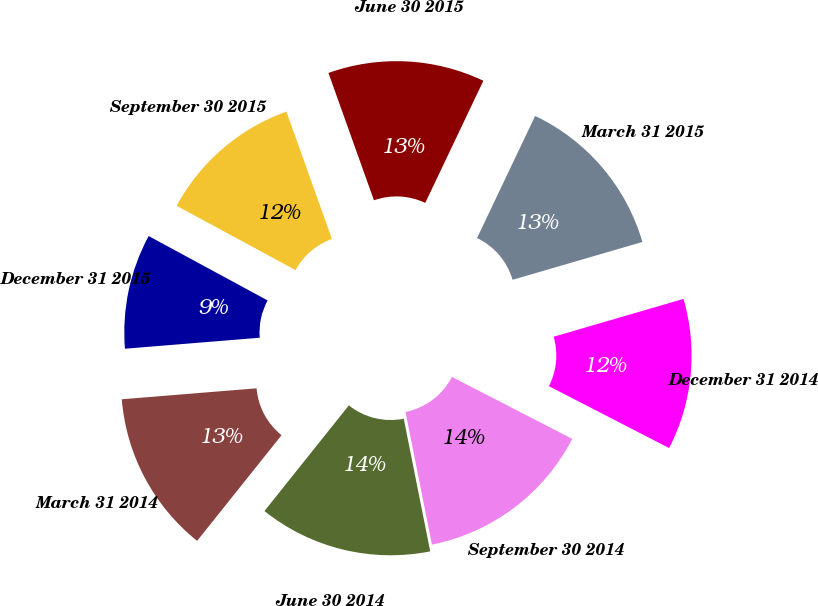<chart> <loc_0><loc_0><loc_500><loc_500><pie_chart><fcel>March 31 2014<fcel>June 30 2014<fcel>September 30 2014<fcel>December 31 2014<fcel>March 31 2015<fcel>June 30 2015<fcel>September 30 2015<fcel>December 31 2015<nl><fcel>12.98%<fcel>13.86%<fcel>14.3%<fcel>12.08%<fcel>13.42%<fcel>12.53%<fcel>11.64%<fcel>9.19%<nl></chart> 